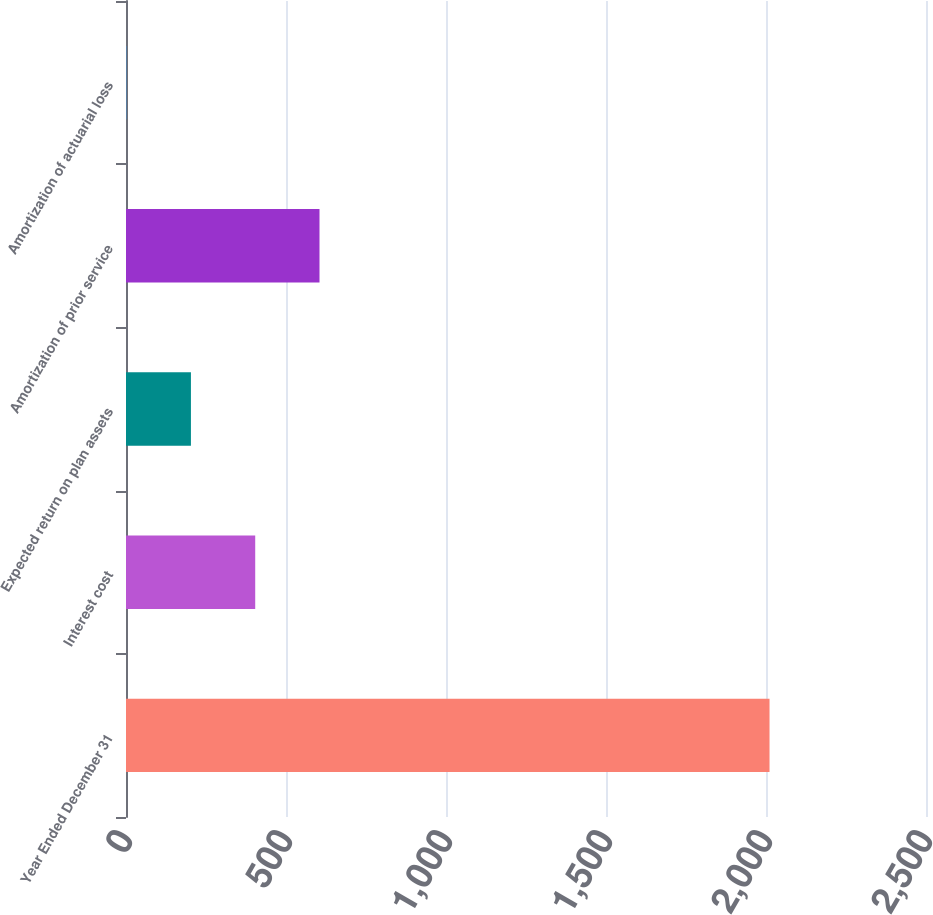Convert chart. <chart><loc_0><loc_0><loc_500><loc_500><bar_chart><fcel>Year Ended December 31<fcel>Interest cost<fcel>Expected return on plan assets<fcel>Amortization of prior service<fcel>Amortization of actuarial loss<nl><fcel>2011<fcel>403.8<fcel>202.9<fcel>604.7<fcel>2<nl></chart> 